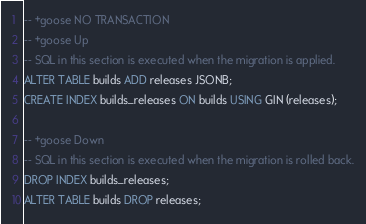Convert code to text. <code><loc_0><loc_0><loc_500><loc_500><_SQL_>-- +goose NO TRANSACTION
-- +goose Up
-- SQL in this section is executed when the migration is applied.
ALTER TABLE builds ADD releases JSONB;
CREATE INDEX builds_releases ON builds USING GIN (releases);

-- +goose Down
-- SQL in this section is executed when the migration is rolled back.
DROP INDEX builds_releases;
ALTER TABLE builds DROP releases;</code> 